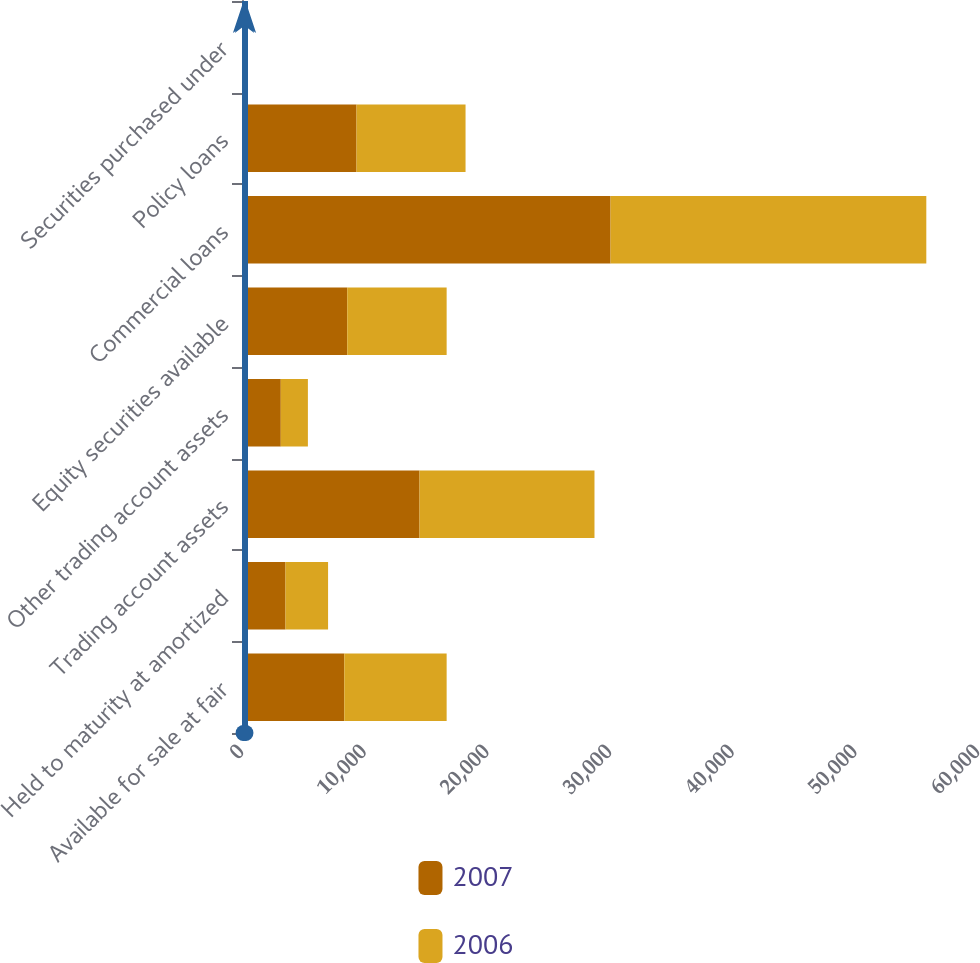Convert chart. <chart><loc_0><loc_0><loc_500><loc_500><stacked_bar_chart><ecel><fcel>Available for sale at fair<fcel>Held to maturity at amortized<fcel>Trading account assets<fcel>Other trading account assets<fcel>Equity securities available<fcel>Commercial loans<fcel>Policy loans<fcel>Securities purchased under<nl><fcel>2007<fcel>8341.5<fcel>3548<fcel>14473<fcel>3163<fcel>8580<fcel>30047<fcel>9337<fcel>129<nl><fcel>2006<fcel>8341.5<fcel>3469<fcel>14262<fcel>2209<fcel>8103<fcel>25739<fcel>8887<fcel>153<nl></chart> 